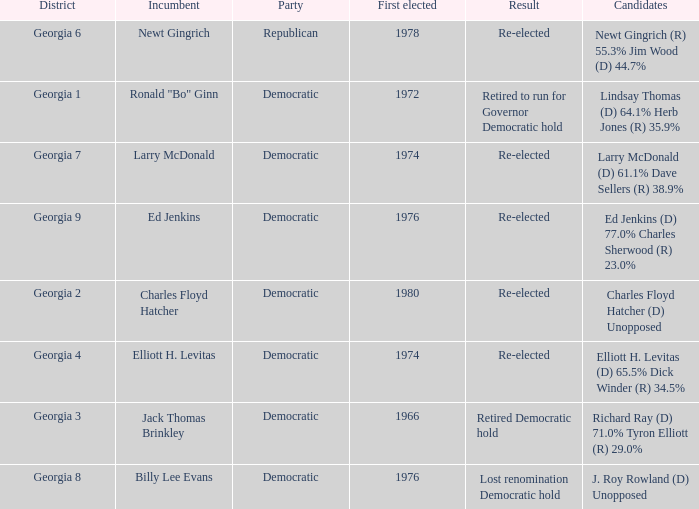What is the name of the party for jack thomas brinkley? Democratic. 